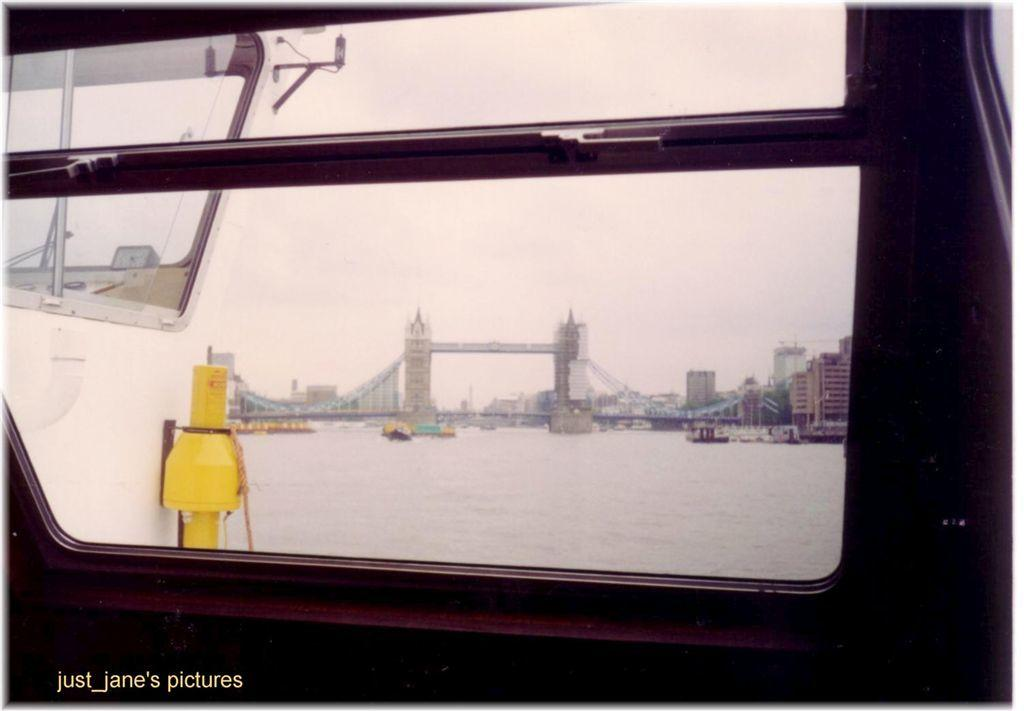What type of structure is located at the bottom of the image? There is a glass window at the bottom of the image. What can be seen through the glass window? A bridge, buildings, water, and the sky are visible through the glass window. Can you describe the view through the glass window? The view includes a bridge, buildings, water, and the sky. Where is the vase placed in the image? There is no vase present in the image. What type of secretary is working at the desk in the image? There is no desk or secretary present in the image. 